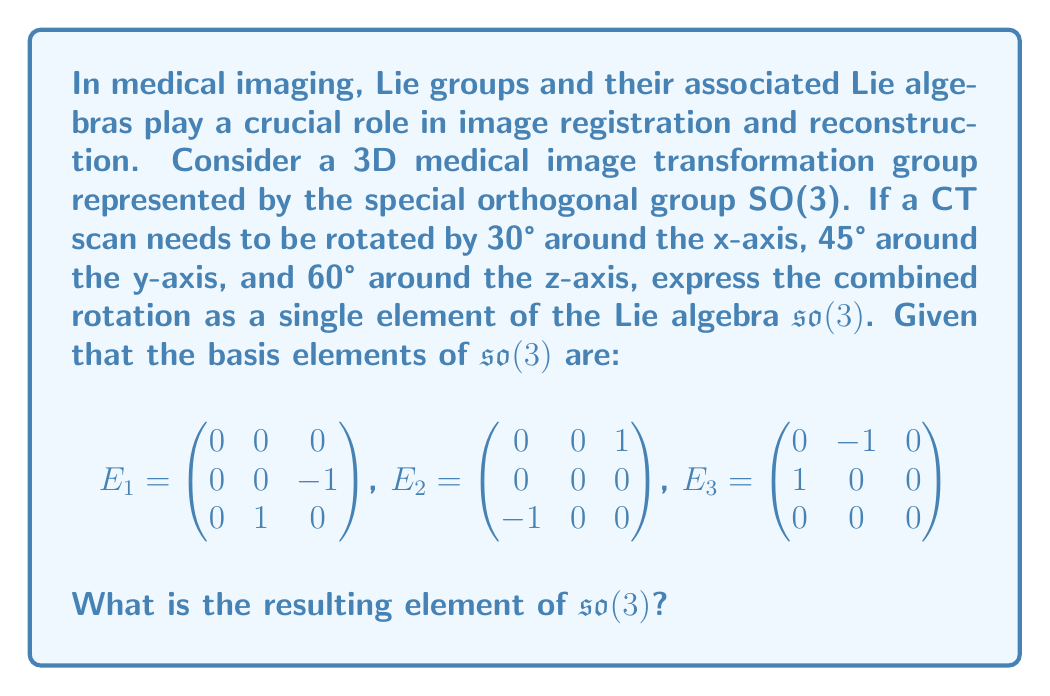Show me your answer to this math problem. To solve this problem, we need to follow these steps:

1) First, recall that rotations in 3D space can be represented by elements of the Lie algebra $\mathfrak{so}(3)$. The relationship between the rotation angle $\theta$ (in radians) around an axis and the corresponding Lie algebra element is given by $\theta E_i$, where $E_i$ is the basis element corresponding to the rotation axis.

2) Convert the given angles to radians:
   30° = $\frac{\pi}{6}$ radians
   45° = $\frac{\pi}{4}$ radians
   60° = $\frac{\pi}{3}$ radians

3) Express each rotation as a Lie algebra element:
   x-axis rotation: $\frac{\pi}{6} E_1$
   y-axis rotation: $\frac{\pi}{4} E_2$
   z-axis rotation: $\frac{\pi}{3} E_3$

4) The combined rotation is the sum of these individual rotations in the Lie algebra:

   $\frac{\pi}{6} E_1 + \frac{\pi}{4} E_2 + \frac{\pi}{3} E_3$

5) Substitute the matrix representations of $E_1$, $E_2$, and $E_3$:

   $\frac{\pi}{6} \begin{pmatrix}
   0 & 0 & 0 \\
   0 & 0 & -1 \\
   0 & 1 & 0
   \end{pmatrix} + 
   \frac{\pi}{4} \begin{pmatrix}
   0 & 0 & 1 \\
   0 & 0 & 0 \\
   -1 & 0 & 0
   \end{pmatrix} + 
   \frac{\pi}{3} \begin{pmatrix}
   0 & -1 & 0 \\
   1 & 0 & 0 \\
   0 & 0 & 0
   \end{pmatrix}$

6) Perform the matrix addition:

   $\begin{pmatrix}
   0 & -\frac{\pi}{3} & \frac{\pi}{4} \\
   \frac{\pi}{3} & 0 & -\frac{\pi}{6} \\
   -\frac{\pi}{4} & \frac{\pi}{6} & 0
   \end{pmatrix}$

This final matrix represents the combined rotation as a single element of the Lie algebra $\mathfrak{so}(3)$.
Answer: $$\begin{pmatrix}
0 & -\frac{\pi}{3} & \frac{\pi}{4} \\
\frac{\pi}{3} & 0 & -\frac{\pi}{6} \\
-\frac{\pi}{4} & \frac{\pi}{6} & 0
\end{pmatrix}$$ 